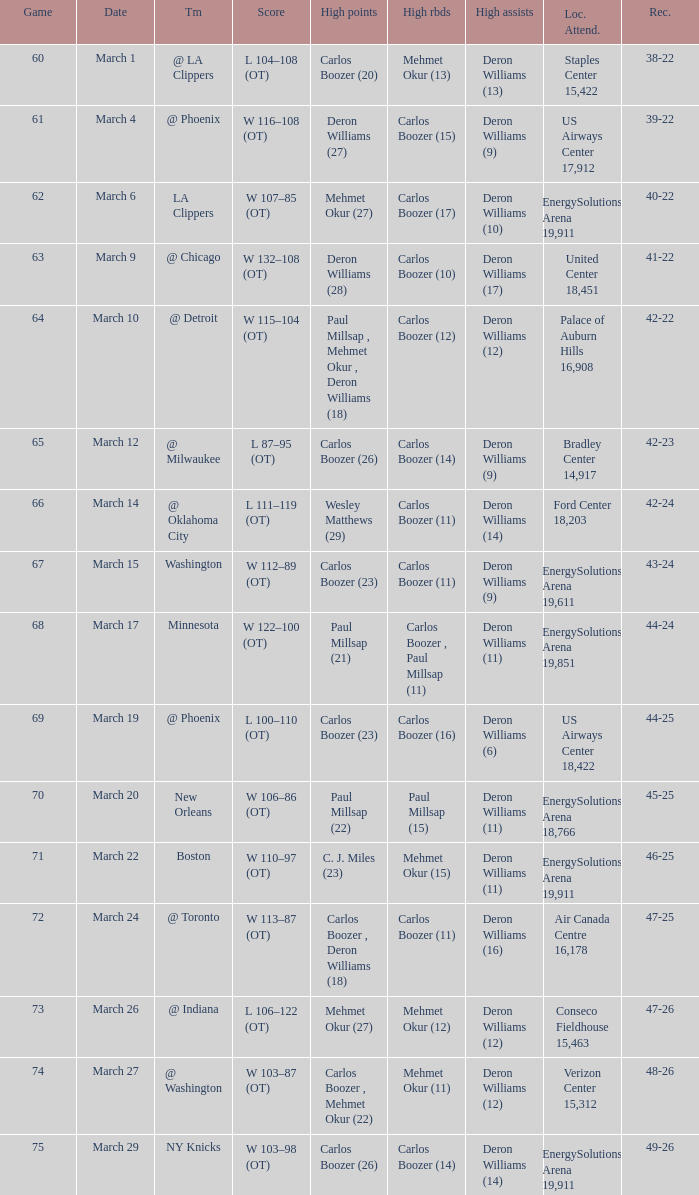How many different players did the most high assists on the March 4 game? 1.0. 